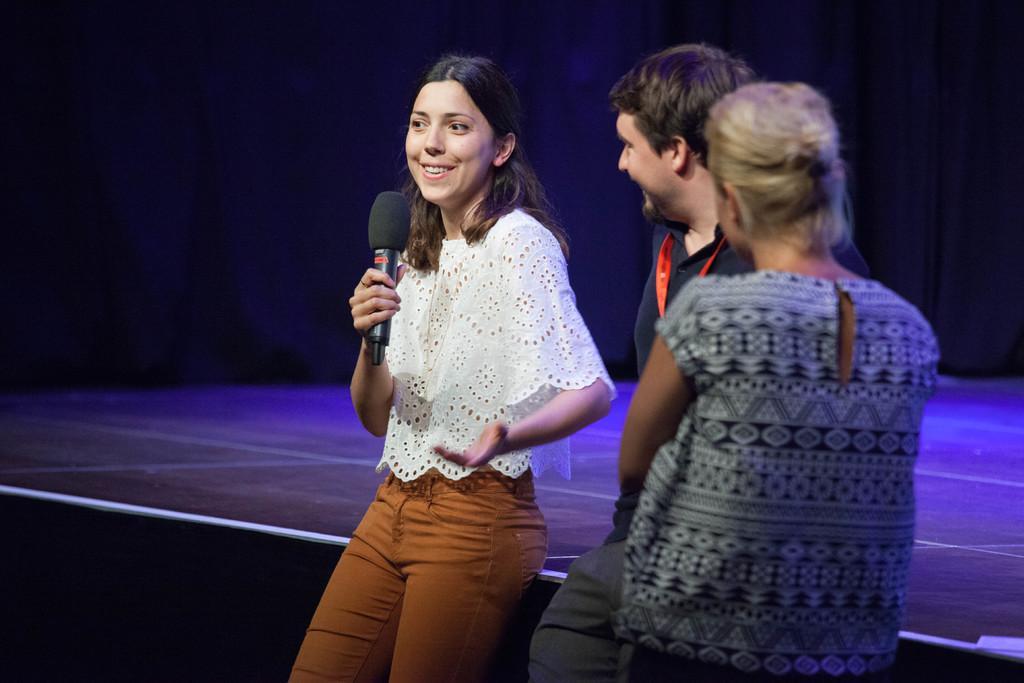Could you give a brief overview of what you see in this image? In this image, there are three persons standing. I can see a woman holding a mike and smiling. Behind the woman, I can see a stage. The background is dark. 